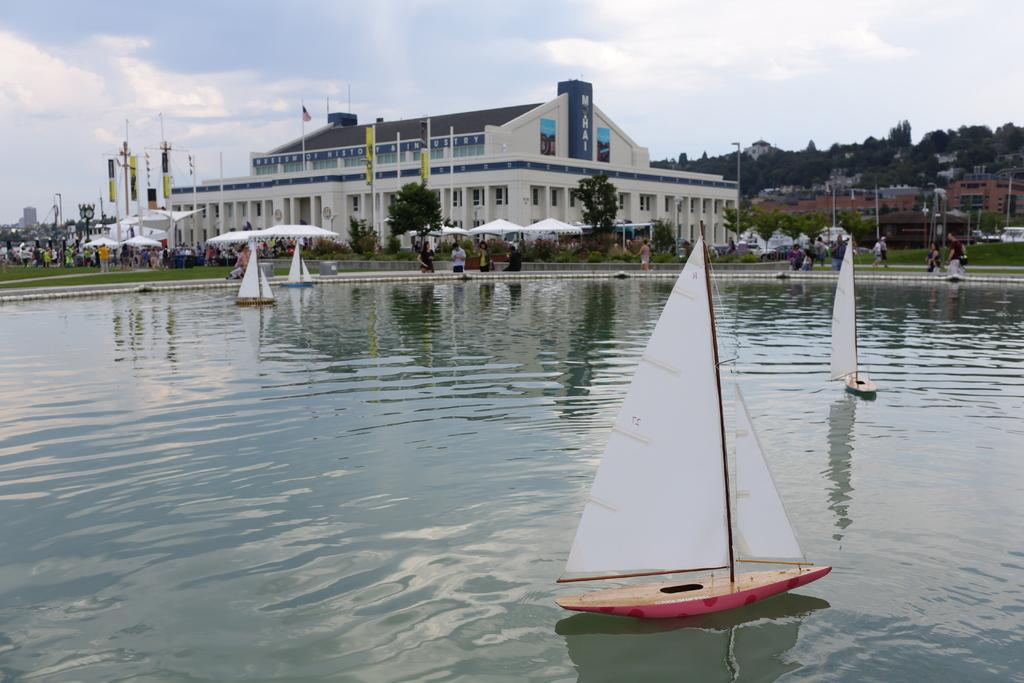What can be seen in the sky in the background of the image? There are clouds visible in the sky in the background of the image. What other elements can be seen in the background of the image? There are trees, a building, people under tents, and people standing and walking in the background of the image. Are there any water-related elements in the image? Yes, there are boats and water visible in the image. What type of beast can be seen using scissors to cut a form in the image? There is no beast, scissors, or form present in the image. 